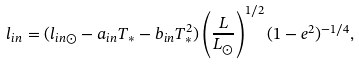Convert formula to latex. <formula><loc_0><loc_0><loc_500><loc_500>l _ { i n } = ( l _ { i n \odot } - a _ { i n } T _ { * } - b _ { i n } T _ { * } ^ { 2 } ) \left ( \frac { L } { L _ { \odot } } \right ) ^ { 1 / 2 } ( 1 - e ^ { 2 } ) ^ { - 1 / 4 } ,</formula> 